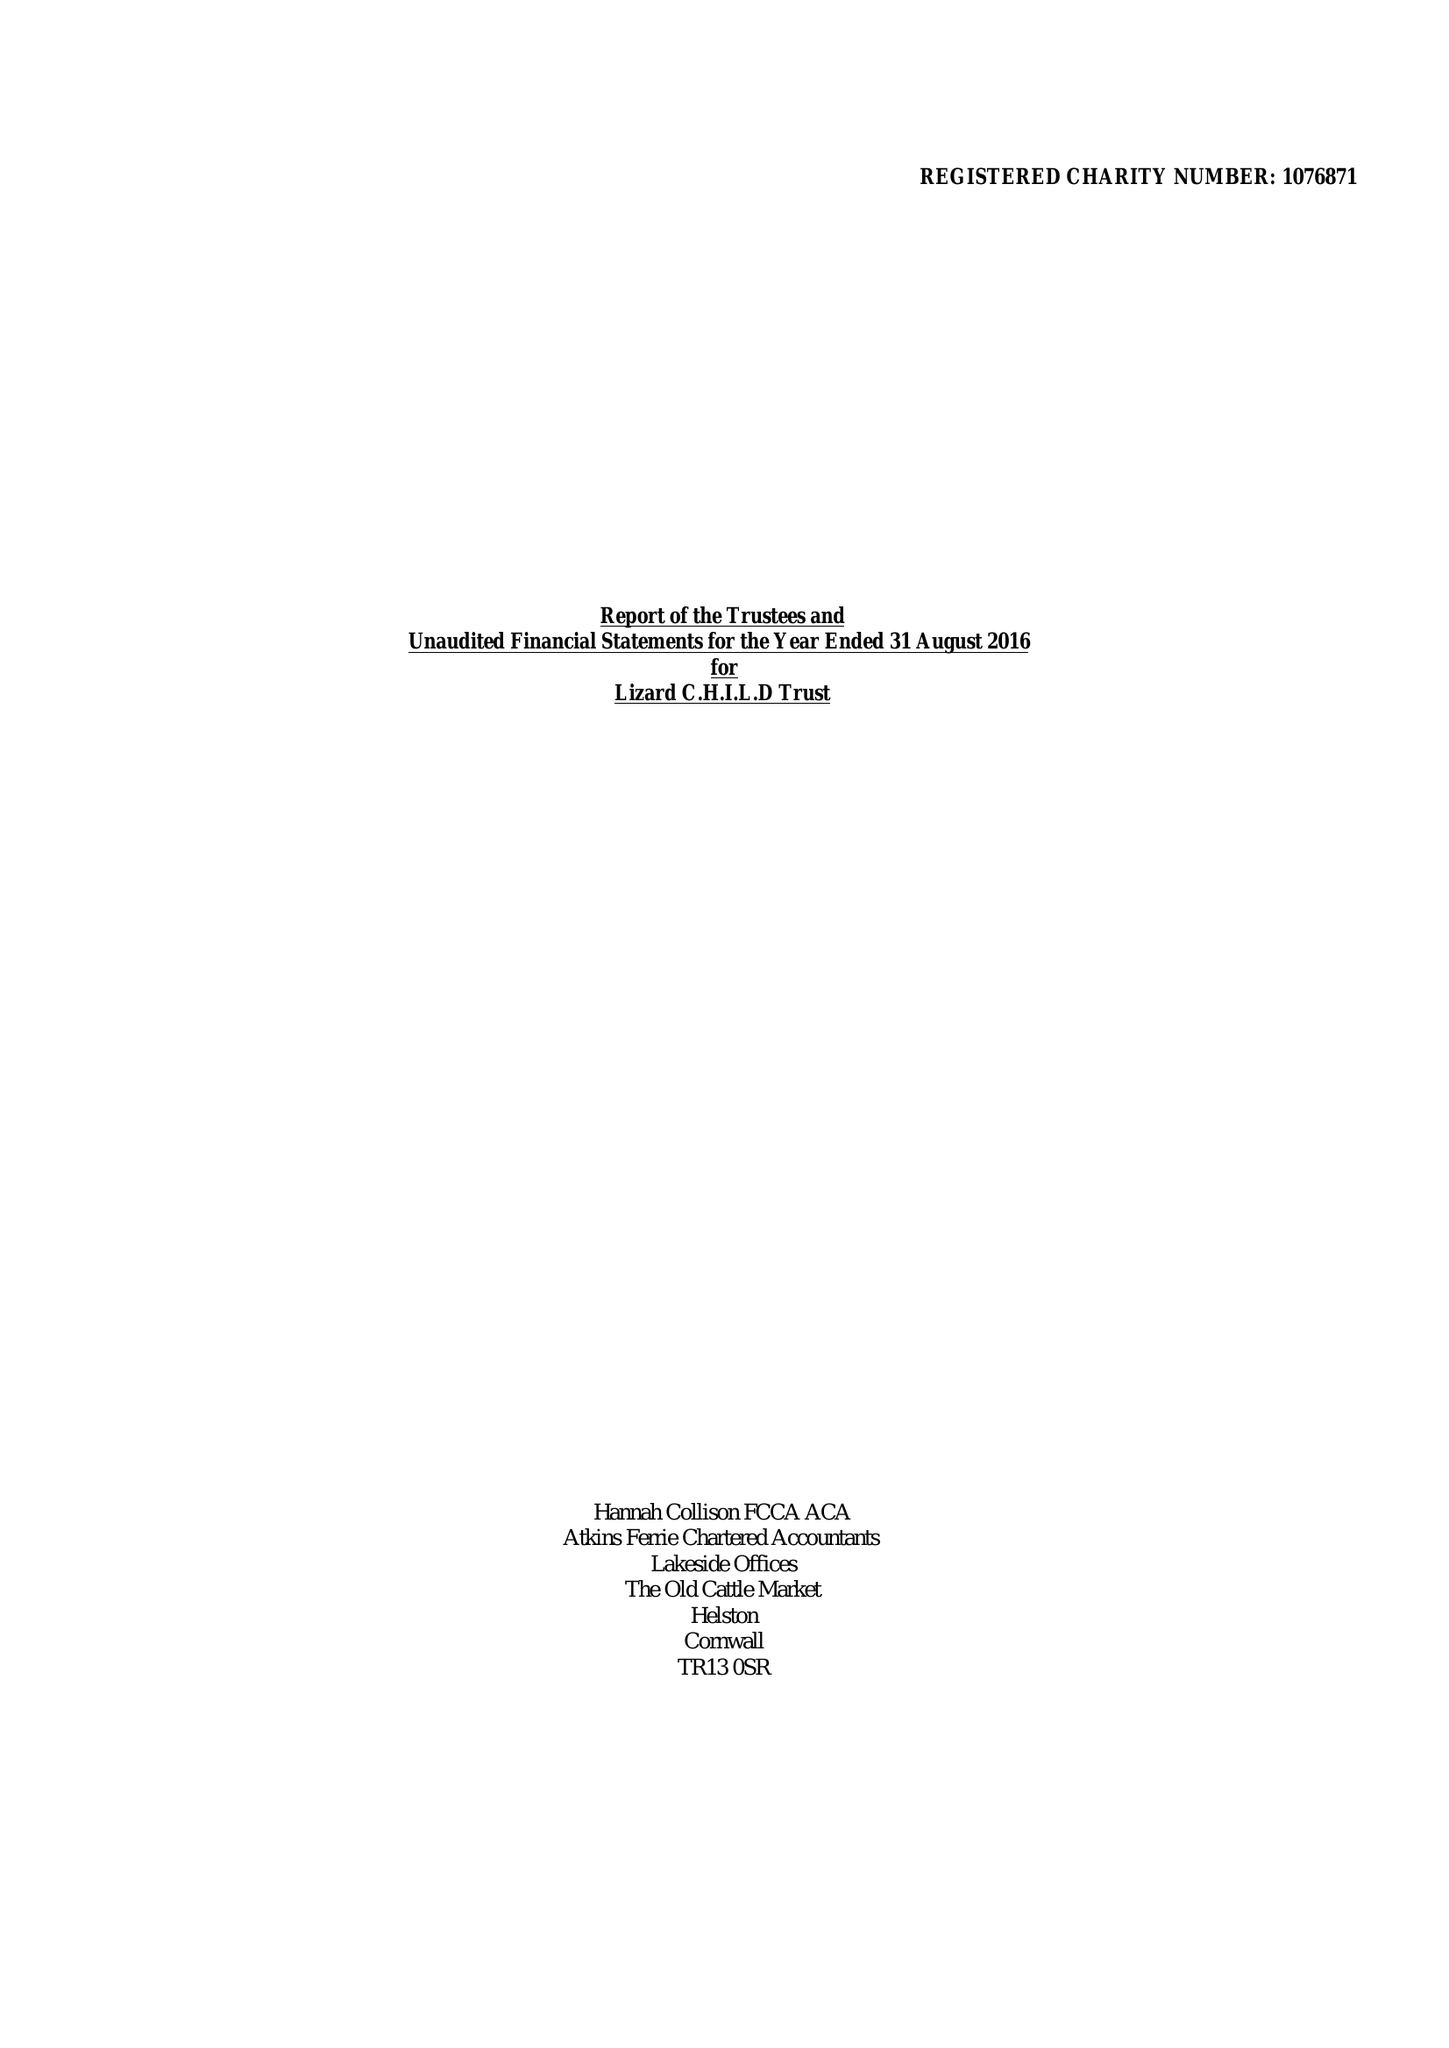What is the value for the address__street_line?
Answer the question using a single word or phrase. PENBERTHY ROAD 